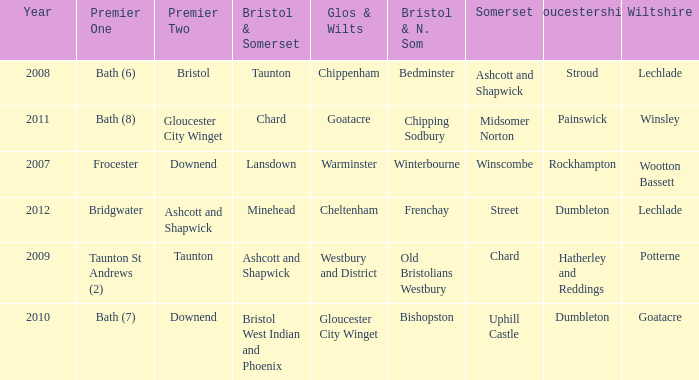What is the year where glos & wilts is gloucester city winget? 2010.0. 